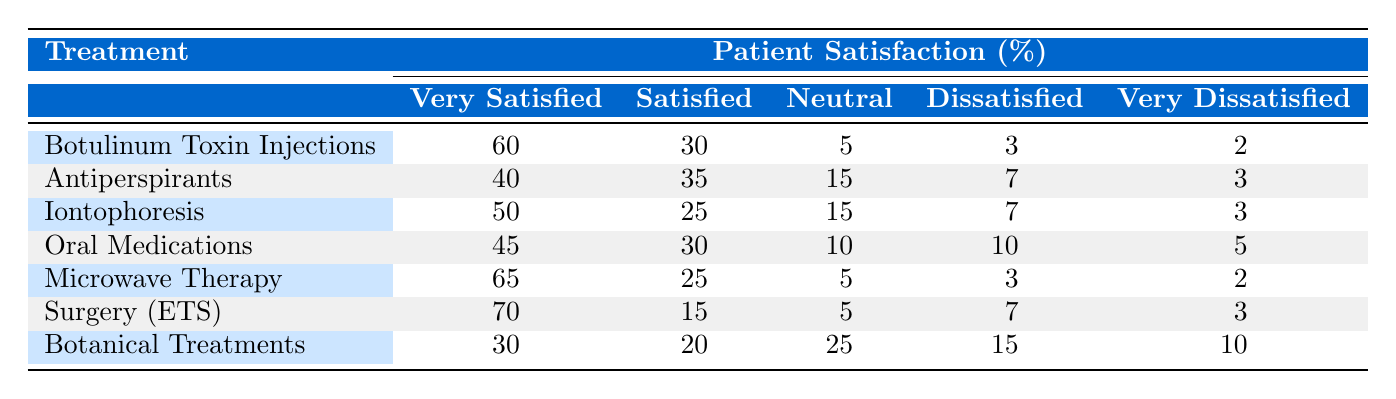What is the patient satisfaction percentage for "Surgery (Endoscopic Thoracic Sympathectomy)" who are very satisfied? From the table, we can see that for "Surgery (Endoscopic Thoracic Sympathectomy)", the percentage of patients who are very satisfied is explicitly listed as 70%.
Answer: 70% Which treatment has the highest percentage of very satisfied patients? By comparing the "very satisfied" percentages listed next to each treatment, "Surgery (Endoscopic Thoracic Sympathectomy)" has the highest at 70%.
Answer: Surgery (Endoscopic Thoracic Sympathectomy) What is the average patient satisfaction percentage for dissatisfied patients across all treatments? Adding up the dissatisfied percentages for each treatment (3 + 7 + 7 + 10 + 3 + 7 + 15 = 52) and dividing by the total number of treatments (7) gives us an average of 52/7 = 7.43%.
Answer: 7.43% Is the patient satisfaction for Iontophoresis greater in the "satisfied" category or the "very satisfied" category? The "satisfied" category for Iontophoresis is 25%, whereas the "very satisfied" category is 50%. Since 50% is greater than 25%, the patient satisfaction is greater in the "very satisfied" category.
Answer: Yes What percentage of patients are either dissatisfied or very dissatisfied for Antiperspirants (Prescription Strength)? By adding the percentages of dissatisfied (7%) and very dissatisfied (3%) patients for Antiperspirants, we get 7% + 3% = 10%.
Answer: 10% Which treatment option has the shortest average duration, and what is that duration? The treatment option with the shortest average duration listed is "Antiperspirants (Prescription Strength)" with a duration of 1 month.
Answer: Antiperspirants (Prescription Strength), 1 month How many treatments have a "very satisfied" percentage of 40% or higher? The treatments with a "very satisfied" percentage of 40% or higher are Botulinum Toxin Injections (60%), Iontophoresis (50%), Oral Medications (45%), Microwave Therapy (65%), and Surgery (70%). Thus, there are 5 treatments that meet this criterion.
Answer: 5 What is the difference in percentage between the very satisfied patients for Microwave Therapy and Botanical Treatments? Microwave Therapy has 65% very satisfied patients, while Botanical Treatments have 30%. The difference is 65% - 30% = 35%.
Answer: 35% How many treatments show neutral satisfaction rates of 15% or more? The treatments that have neutral satisfaction rates of 15% or more are Antiperspirants (15%), Iontophoresis (15%), and Botanical Treatments (25%). This gives us a total of 3 treatments.
Answer: 3 Is the patient satisfaction level for Microwave Therapy higher than that for Oral Medications across all satisfaction categories? Analyzing each satisfaction category, we find that Microwave Therapy has higher percentages than Oral Medications in the very satisfied (65% vs 45%), satisfied (25% vs 30%), neutral (5% vs 10%), dissatisfied (3% vs 10%), and very dissatisfied (2% vs 5%) categories. Thus, overall Microwave Therapy shows higher satisfaction.
Answer: Yes 